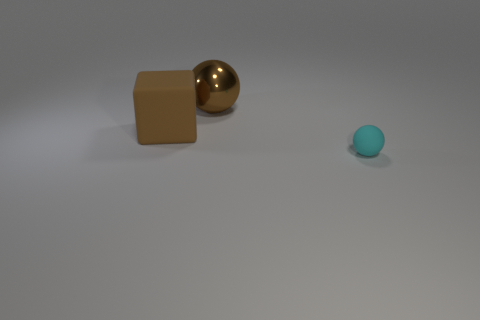How many other objects are the same material as the brown block?
Offer a very short reply. 1. Is there anything else that has the same size as the metallic thing?
Offer a very short reply. Yes. Is the number of metallic things greater than the number of yellow metallic blocks?
Give a very brief answer. Yes. There is a object right of the big thing behind the brown thing that is to the left of the large brown metallic ball; what is its size?
Offer a very short reply. Small. There is a brown cube; is it the same size as the sphere to the left of the tiny cyan sphere?
Provide a succinct answer. Yes. Are there fewer brown metallic things that are to the left of the large ball than yellow matte blocks?
Offer a very short reply. No. How many big metallic balls are the same color as the rubber cube?
Your answer should be compact. 1. Is the number of large rubber objects less than the number of small matte cylinders?
Ensure brevity in your answer.  No. Is the big brown cube made of the same material as the tiny cyan sphere?
Your answer should be very brief. Yes. What number of other objects are there of the same size as the metal object?
Ensure brevity in your answer.  1. 